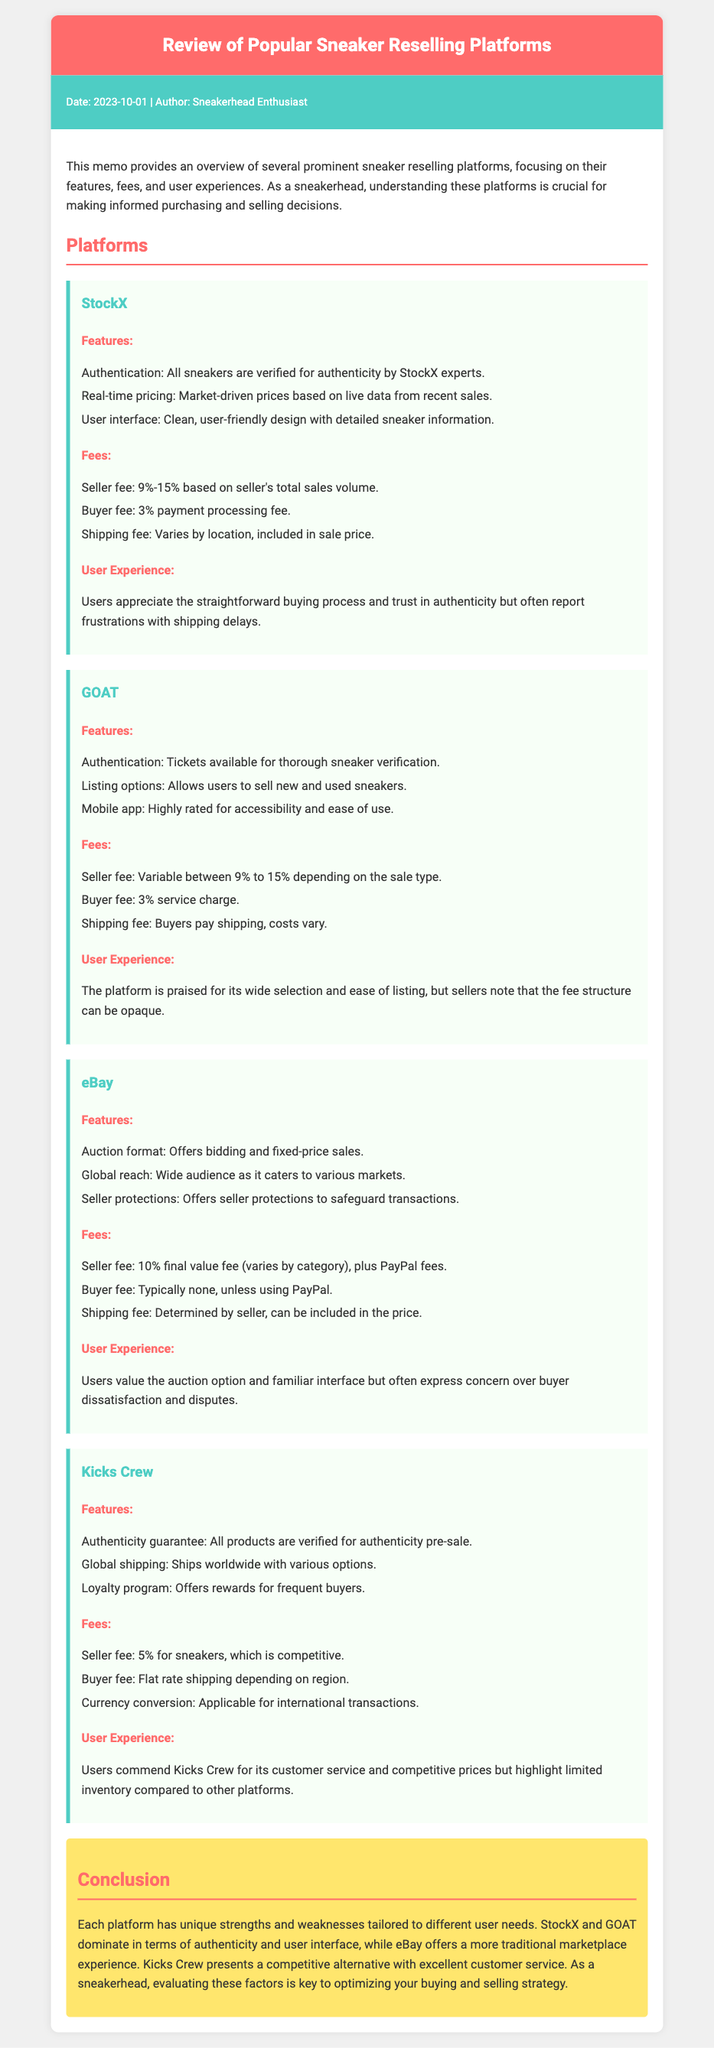what is the seller fee range for StockX? The seller fee for StockX ranges from 9% to 15% based on the seller's total sales volume.
Answer: 9%-15% how does GOAT ensure sneaker authenticity? GOAT verifies sneakers through their tickets available for thorough sneaker verification.
Answer: Tickets what is the fee type applied when buying on eBay? eBay typically does not charge a buyer fee unless using PayPal.
Answer: None which platform offers a loyalty program? Kicks Crew has a loyalty program that offers rewards for frequent buyers.
Answer: Kicks Crew what is a common user experience feedback for StockX? Users report frustrations with shipping delays when using StockX.
Answer: Shipping delays what platform allows for both new and used sneaker sales? GOAT allows users to sell both new and used sneakers.
Answer: GOAT when was the memo published? The memo was published on 2023-10-01.
Answer: 2023-10-01 what unique feature does eBay offer compared to other platforms? eBay offers an auction format for bidding on sneakers.
Answer: Auction format what is the user rating feedback for the mobile app of GOAT? The mobile app of GOAT is highly rated for accessibility and ease of use.
Answer: Highly rated 